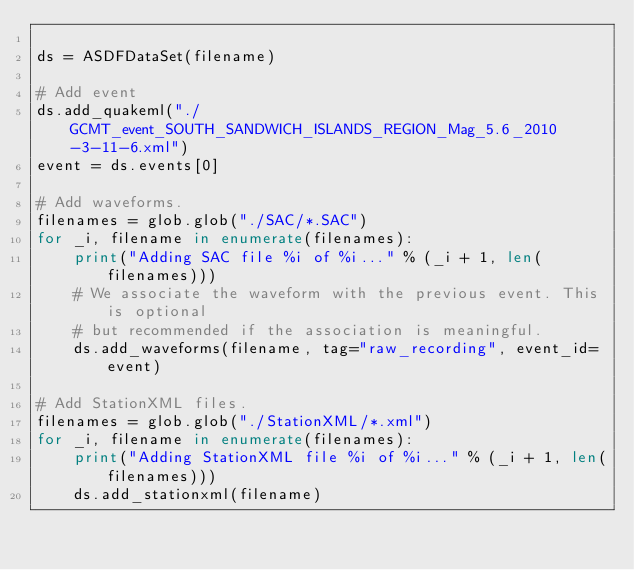Convert code to text. <code><loc_0><loc_0><loc_500><loc_500><_Python_>
ds = ASDFDataSet(filename)

# Add event
ds.add_quakeml("./GCMT_event_SOUTH_SANDWICH_ISLANDS_REGION_Mag_5.6_2010-3-11-6.xml")
event = ds.events[0]

# Add waveforms.
filenames = glob.glob("./SAC/*.SAC")
for _i, filename in enumerate(filenames):
    print("Adding SAC file %i of %i..." % (_i + 1, len(filenames)))
    # We associate the waveform with the previous event. This is optional
    # but recommended if the association is meaningful.
    ds.add_waveforms(filename, tag="raw_recording", event_id=event)

# Add StationXML files.
filenames = glob.glob("./StationXML/*.xml")
for _i, filename in enumerate(filenames):
    print("Adding StationXML file %i of %i..." % (_i + 1, len(filenames)))
    ds.add_stationxml(filename)
</code> 